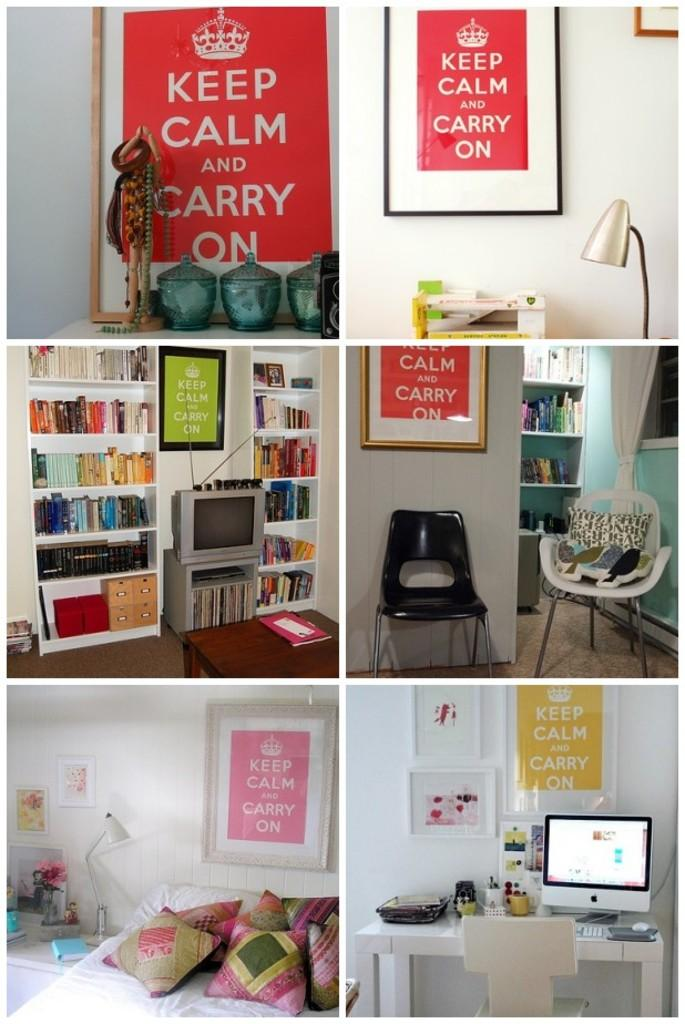What is the color of the wall in the image? The wall in the image is white. What type of lighting fixture is present in the image? There is a lamp in the image. What is used for displaying photos or artwork in the image? There is a photo frame in the image. What is used for storage or displaying items in the image? There are shelves in the image. What type of furniture is present for sitting in the image? There is a chair in the image. What type of furniture is present for sleeping in the image? There is a bed in the image. What type of electronic device is present in the image? There is a screen in the image. What type of soft cushioning is present in the image? There are pillows in the image. How many pies are being served on the chair in the image? There are no pies present in the image; the chair is used for sitting. What type of plant is growing on the bed in the image? There are no plants present in the image, and the bed is used for sleeping. 